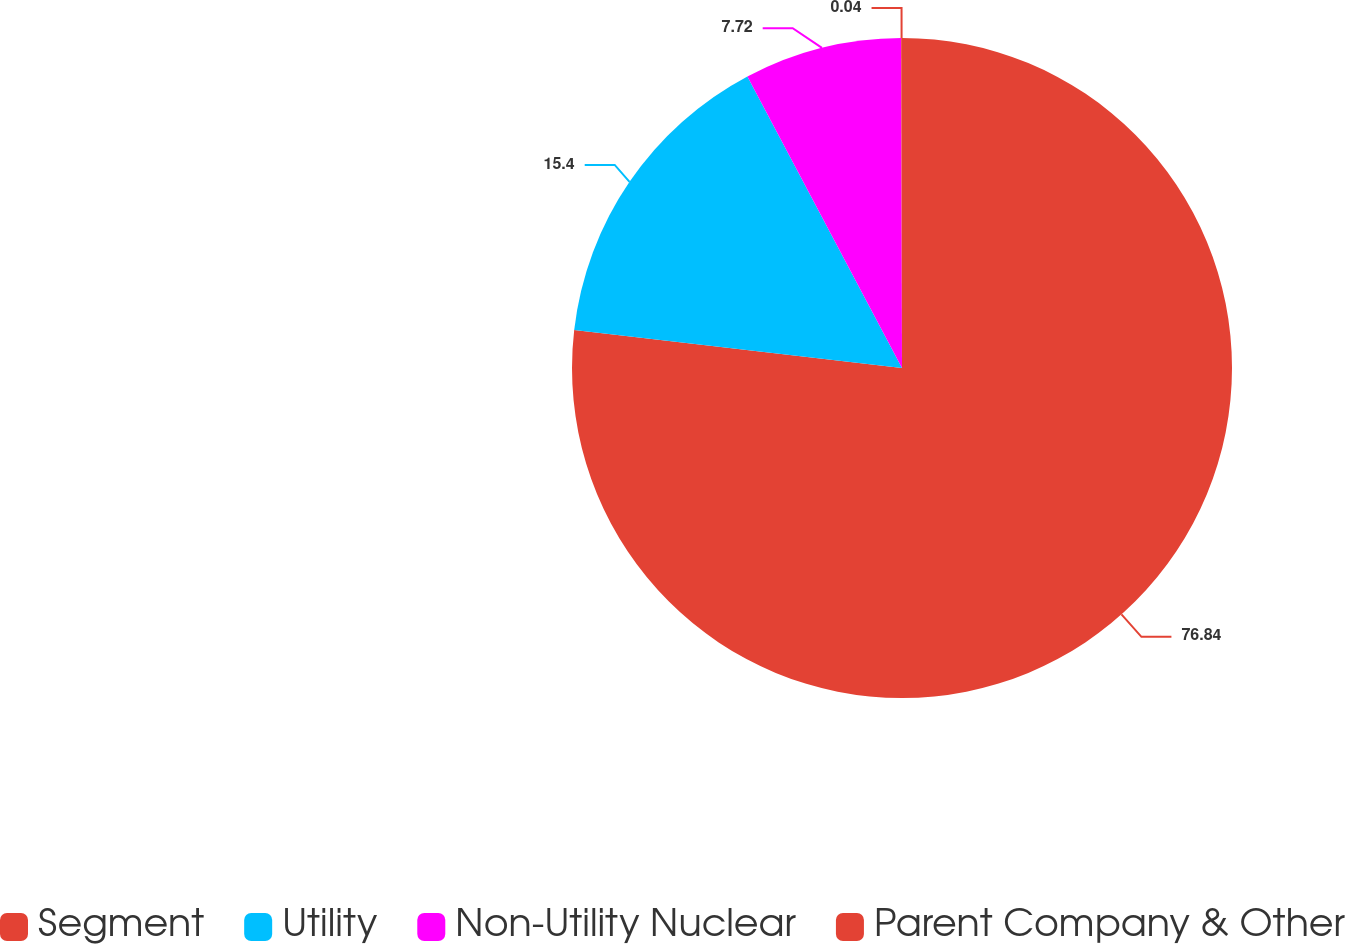Convert chart to OTSL. <chart><loc_0><loc_0><loc_500><loc_500><pie_chart><fcel>Segment<fcel>Utility<fcel>Non-Utility Nuclear<fcel>Parent Company & Other<nl><fcel>76.84%<fcel>15.4%<fcel>7.72%<fcel>0.04%<nl></chart> 